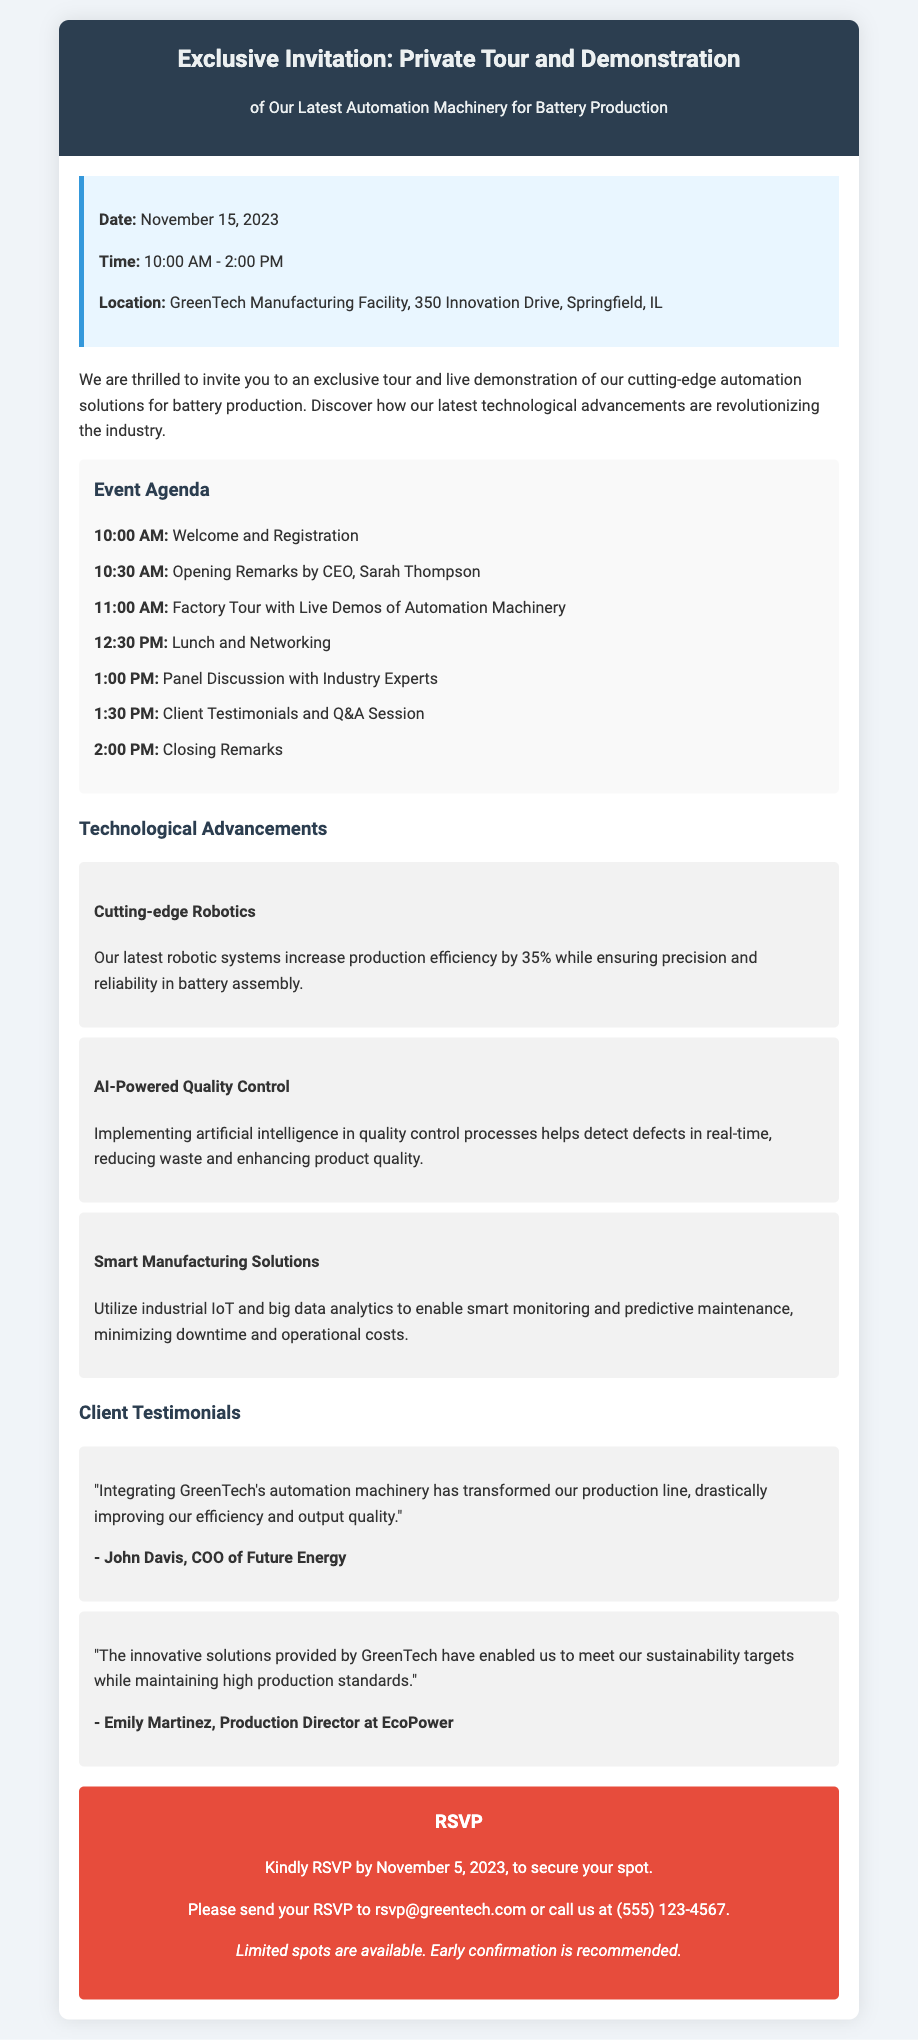What is the date of the event? The date of the event is clearly stated in the information section of the document.
Answer: November 15, 2023 What time does the event start? The starting time is provided in the information section.
Answer: 10:00 AM Who is giving the opening remarks? The document mentions the person giving the opening remarks in the agenda.
Answer: Sarah Thompson How many testimonials are featured in the document? The number of testimonials can be counted in the testimonials section.
Answer: Two What is one of the features of the latest robotic systems? The technological advancements section describes a feature of the robotic systems.
Answer: Increase production efficiency by 35% What should participants do to RSVP? The RSVP section explains how to confirm attendance.
Answer: Send an email or call When is the RSVP deadline? The deadline for RSVP is clearly mentioned in the RSVP section.
Answer: November 5, 2023 What type of event is this document related to? The main purpose of the document is specified in the introduction.
Answer: Private tour and demonstration 